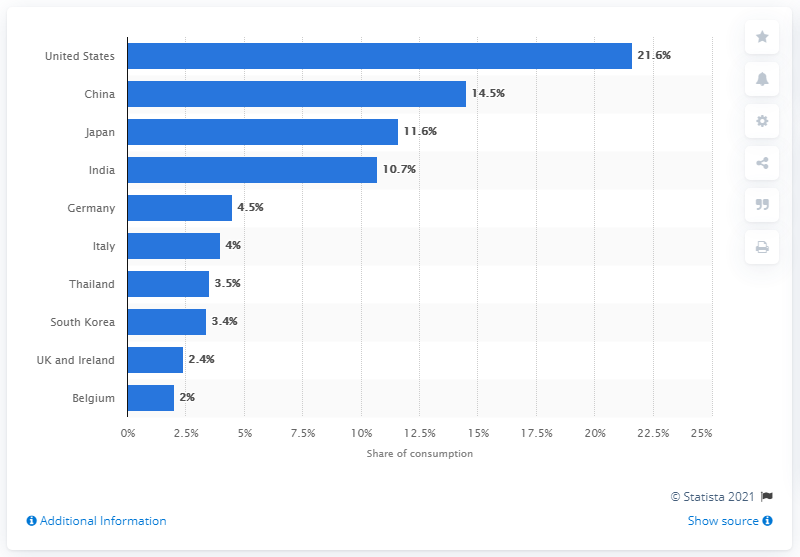Mention a couple of crucial points in this snapshot. In 2010, the United States accounted for approximately 21.6% of the global silver production demand. 